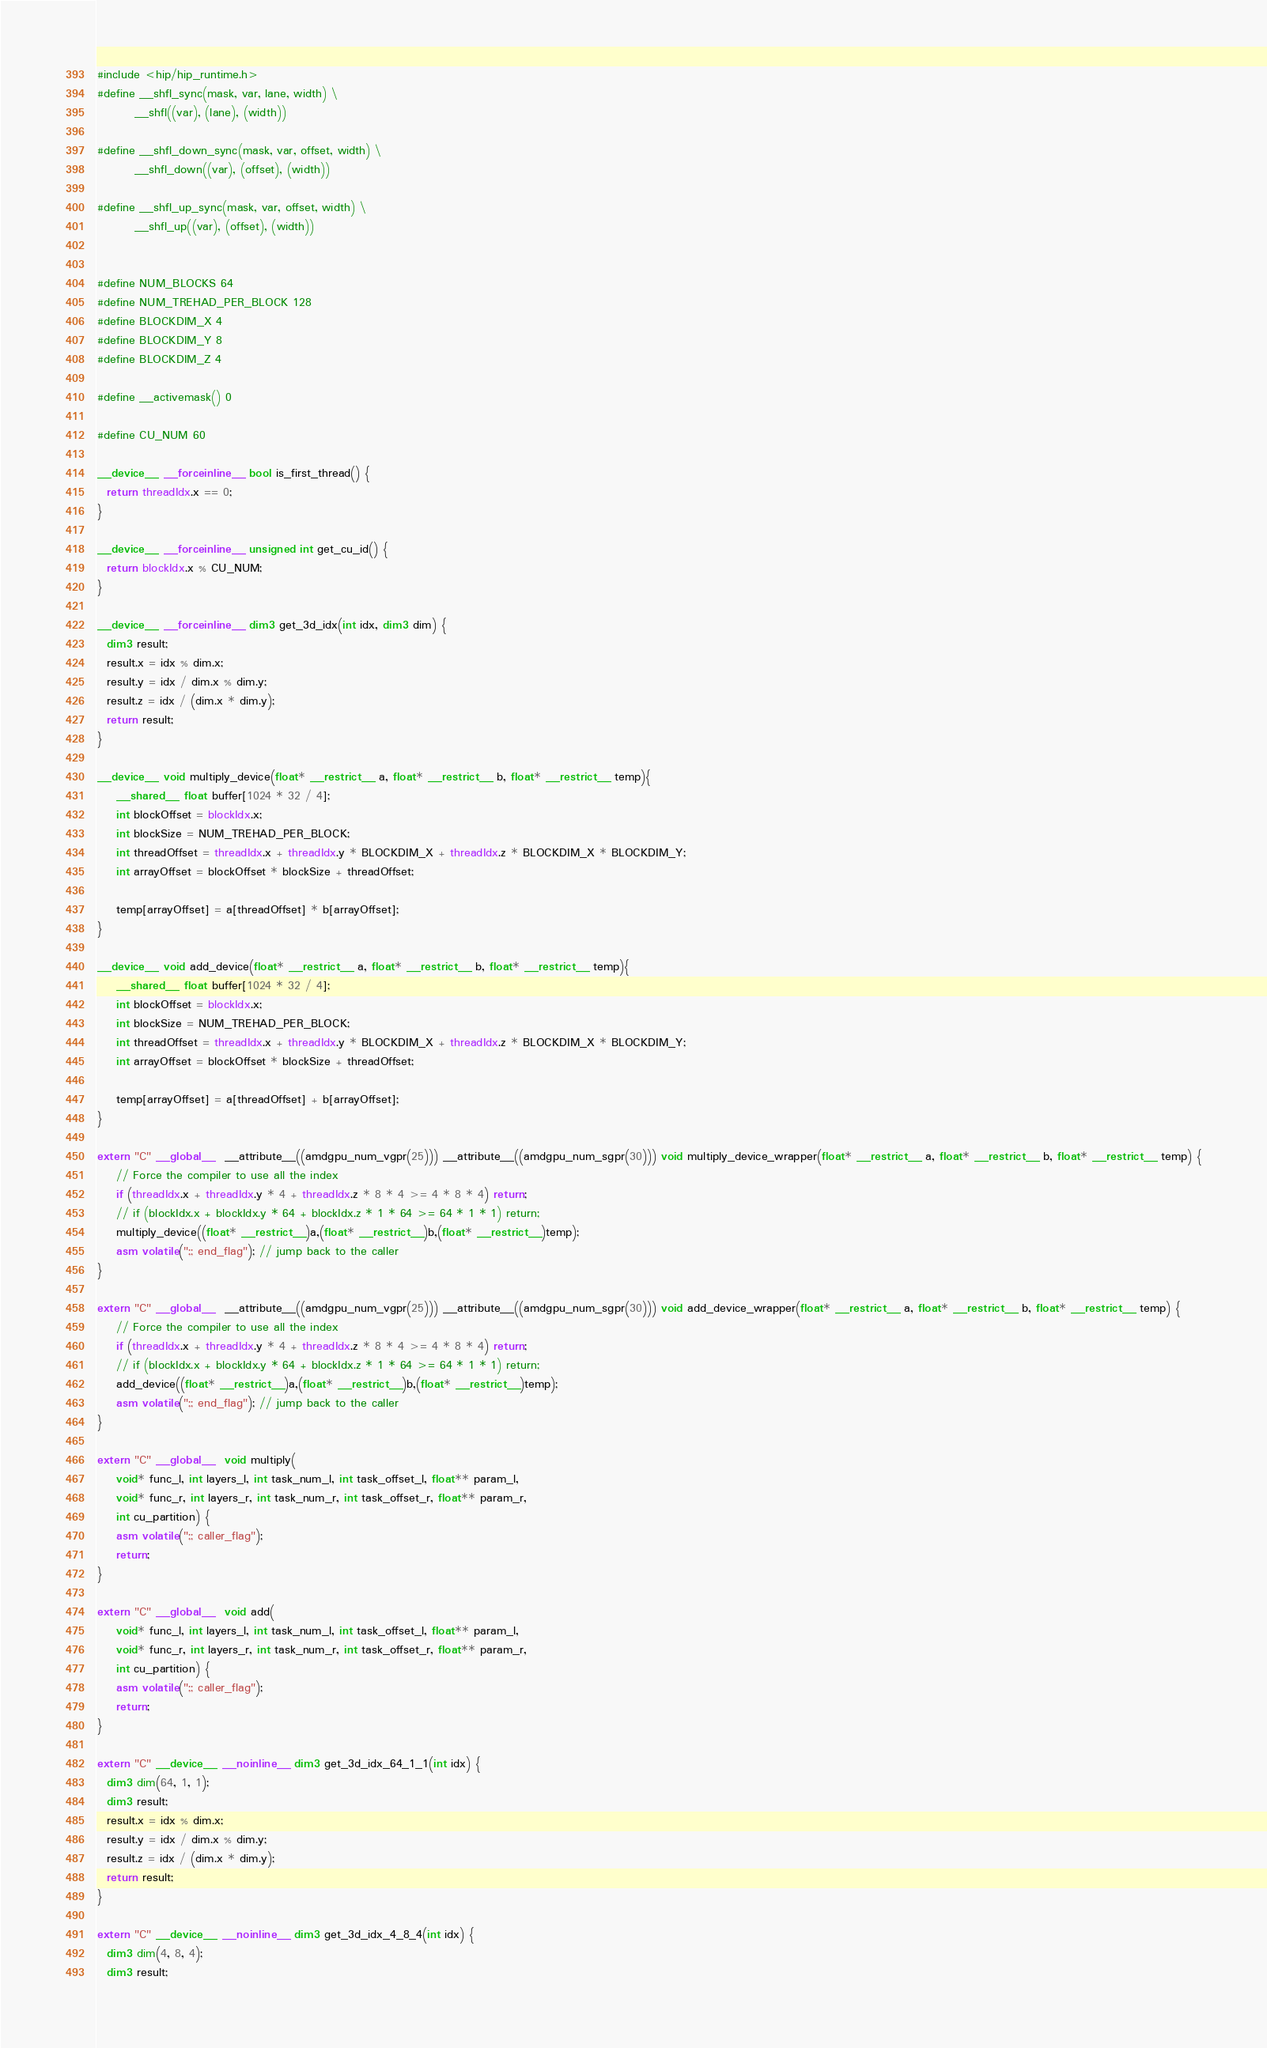Convert code to text. <code><loc_0><loc_0><loc_500><loc_500><_Cuda_>#include <hip/hip_runtime.h>
#define __shfl_sync(mask, var, lane, width) \
        __shfl((var), (lane), (width))

#define __shfl_down_sync(mask, var, offset, width) \
        __shfl_down((var), (offset), (width))

#define __shfl_up_sync(mask, var, offset, width) \
        __shfl_up((var), (offset), (width))


#define NUM_BLOCKS 64
#define NUM_TREHAD_PER_BLOCK 128
#define BLOCKDIM_X 4
#define BLOCKDIM_Y 8
#define BLOCKDIM_Z 4

#define __activemask() 0

#define CU_NUM 60

__device__ __forceinline__ bool is_first_thread() {
  return threadIdx.x == 0;
}

__device__ __forceinline__ unsigned int get_cu_id() {
  return blockIdx.x % CU_NUM;
}

__device__ __forceinline__ dim3 get_3d_idx(int idx, dim3 dim) {
  dim3 result;
  result.x = idx % dim.x;
  result.y = idx / dim.x % dim.y;
  result.z = idx / (dim.x * dim.y);
  return result;
}

__device__ void multiply_device(float* __restrict__ a, float* __restrict__ b, float* __restrict__ temp){
    __shared__ float buffer[1024 * 32 / 4];
    int blockOffset = blockIdx.x;
    int blockSize = NUM_TREHAD_PER_BLOCK;
    int threadOffset = threadIdx.x + threadIdx.y * BLOCKDIM_X + threadIdx.z * BLOCKDIM_X * BLOCKDIM_Y;
    int arrayOffset = blockOffset * blockSize + threadOffset;

    temp[arrayOffset] = a[threadOffset] * b[arrayOffset];
}

__device__ void add_device(float* __restrict__ a, float* __restrict__ b, float* __restrict__ temp){
    __shared__ float buffer[1024 * 32 / 4];
    int blockOffset = blockIdx.x;
    int blockSize = NUM_TREHAD_PER_BLOCK;
    int threadOffset = threadIdx.x + threadIdx.y * BLOCKDIM_X + threadIdx.z * BLOCKDIM_X * BLOCKDIM_Y;
    int arrayOffset = blockOffset * blockSize + threadOffset;

    temp[arrayOffset] = a[threadOffset] + b[arrayOffset];
}

extern "C" __global__  __attribute__((amdgpu_num_vgpr(25))) __attribute__((amdgpu_num_sgpr(30))) void multiply_device_wrapper(float* __restrict__ a, float* __restrict__ b, float* __restrict__ temp) {
    // Force the compiler to use all the index
    if (threadIdx.x + threadIdx.y * 4 + threadIdx.z * 8 * 4 >= 4 * 8 * 4) return;
    // if (blockIdx.x + blockIdx.y * 64 + blockIdx.z * 1 * 64 >= 64 * 1 * 1) return;
    multiply_device((float* __restrict__)a,(float* __restrict__)b,(float* __restrict__)temp);
    asm volatile(";; end_flag"); // jump back to the caller
}

extern "C" __global__  __attribute__((amdgpu_num_vgpr(25))) __attribute__((amdgpu_num_sgpr(30))) void add_device_wrapper(float* __restrict__ a, float* __restrict__ b, float* __restrict__ temp) {
    // Force the compiler to use all the index
    if (threadIdx.x + threadIdx.y * 4 + threadIdx.z * 8 * 4 >= 4 * 8 * 4) return;
    // if (blockIdx.x + blockIdx.y * 64 + blockIdx.z * 1 * 64 >= 64 * 1 * 1) return;
    add_device((float* __restrict__)a,(float* __restrict__)b,(float* __restrict__)temp);
    asm volatile(";; end_flag"); // jump back to the caller
}

extern "C" __global__  void multiply(
    void* func_l, int layers_l, int task_num_l, int task_offset_l, float** param_l,
    void* func_r, int layers_r, int task_num_r, int task_offset_r, float** param_r,
    int cu_partition) {
    asm volatile(";; caller_flag");
    return;
}

extern "C" __global__  void add(
    void* func_l, int layers_l, int task_num_l, int task_offset_l, float** param_l,
    void* func_r, int layers_r, int task_num_r, int task_offset_r, float** param_r,
    int cu_partition) {
    asm volatile(";; caller_flag");
    return;
}

extern "C" __device__ __noinline__ dim3 get_3d_idx_64_1_1(int idx) {
  dim3 dim(64, 1, 1);
  dim3 result;
  result.x = idx % dim.x;
  result.y = idx / dim.x % dim.y;
  result.z = idx / (dim.x * dim.y);
  return result;
}

extern "C" __device__ __noinline__ dim3 get_3d_idx_4_8_4(int idx) {
  dim3 dim(4, 8, 4);
  dim3 result;</code> 